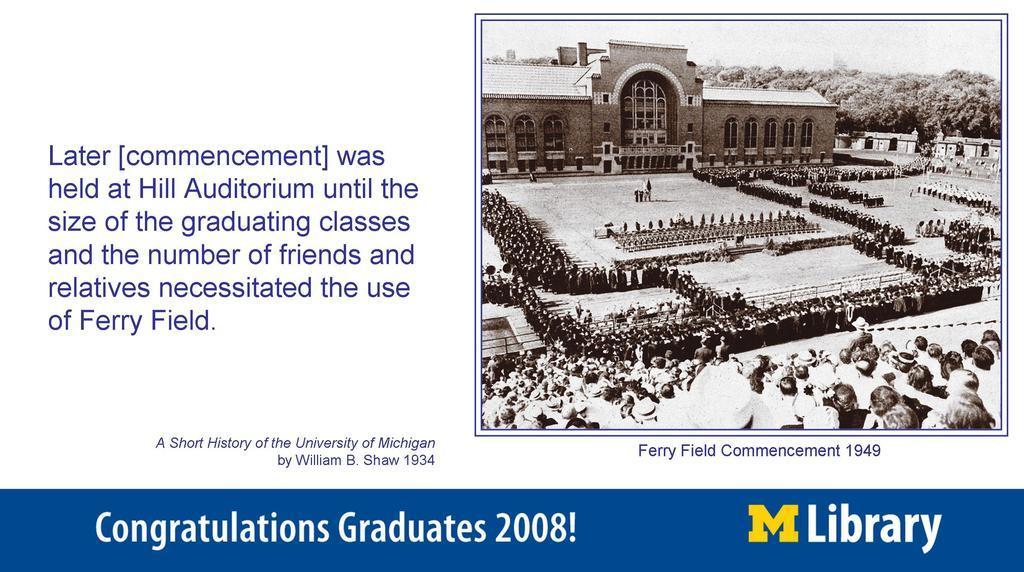Could you give a brief overview of what you see in this image? In this image there is a poster with some text. Beside the text there is a old photograph. In the photograph there is a building. In front of the building there are people sitting and standing in an organised way. In the background of the image there are trees and sky. 